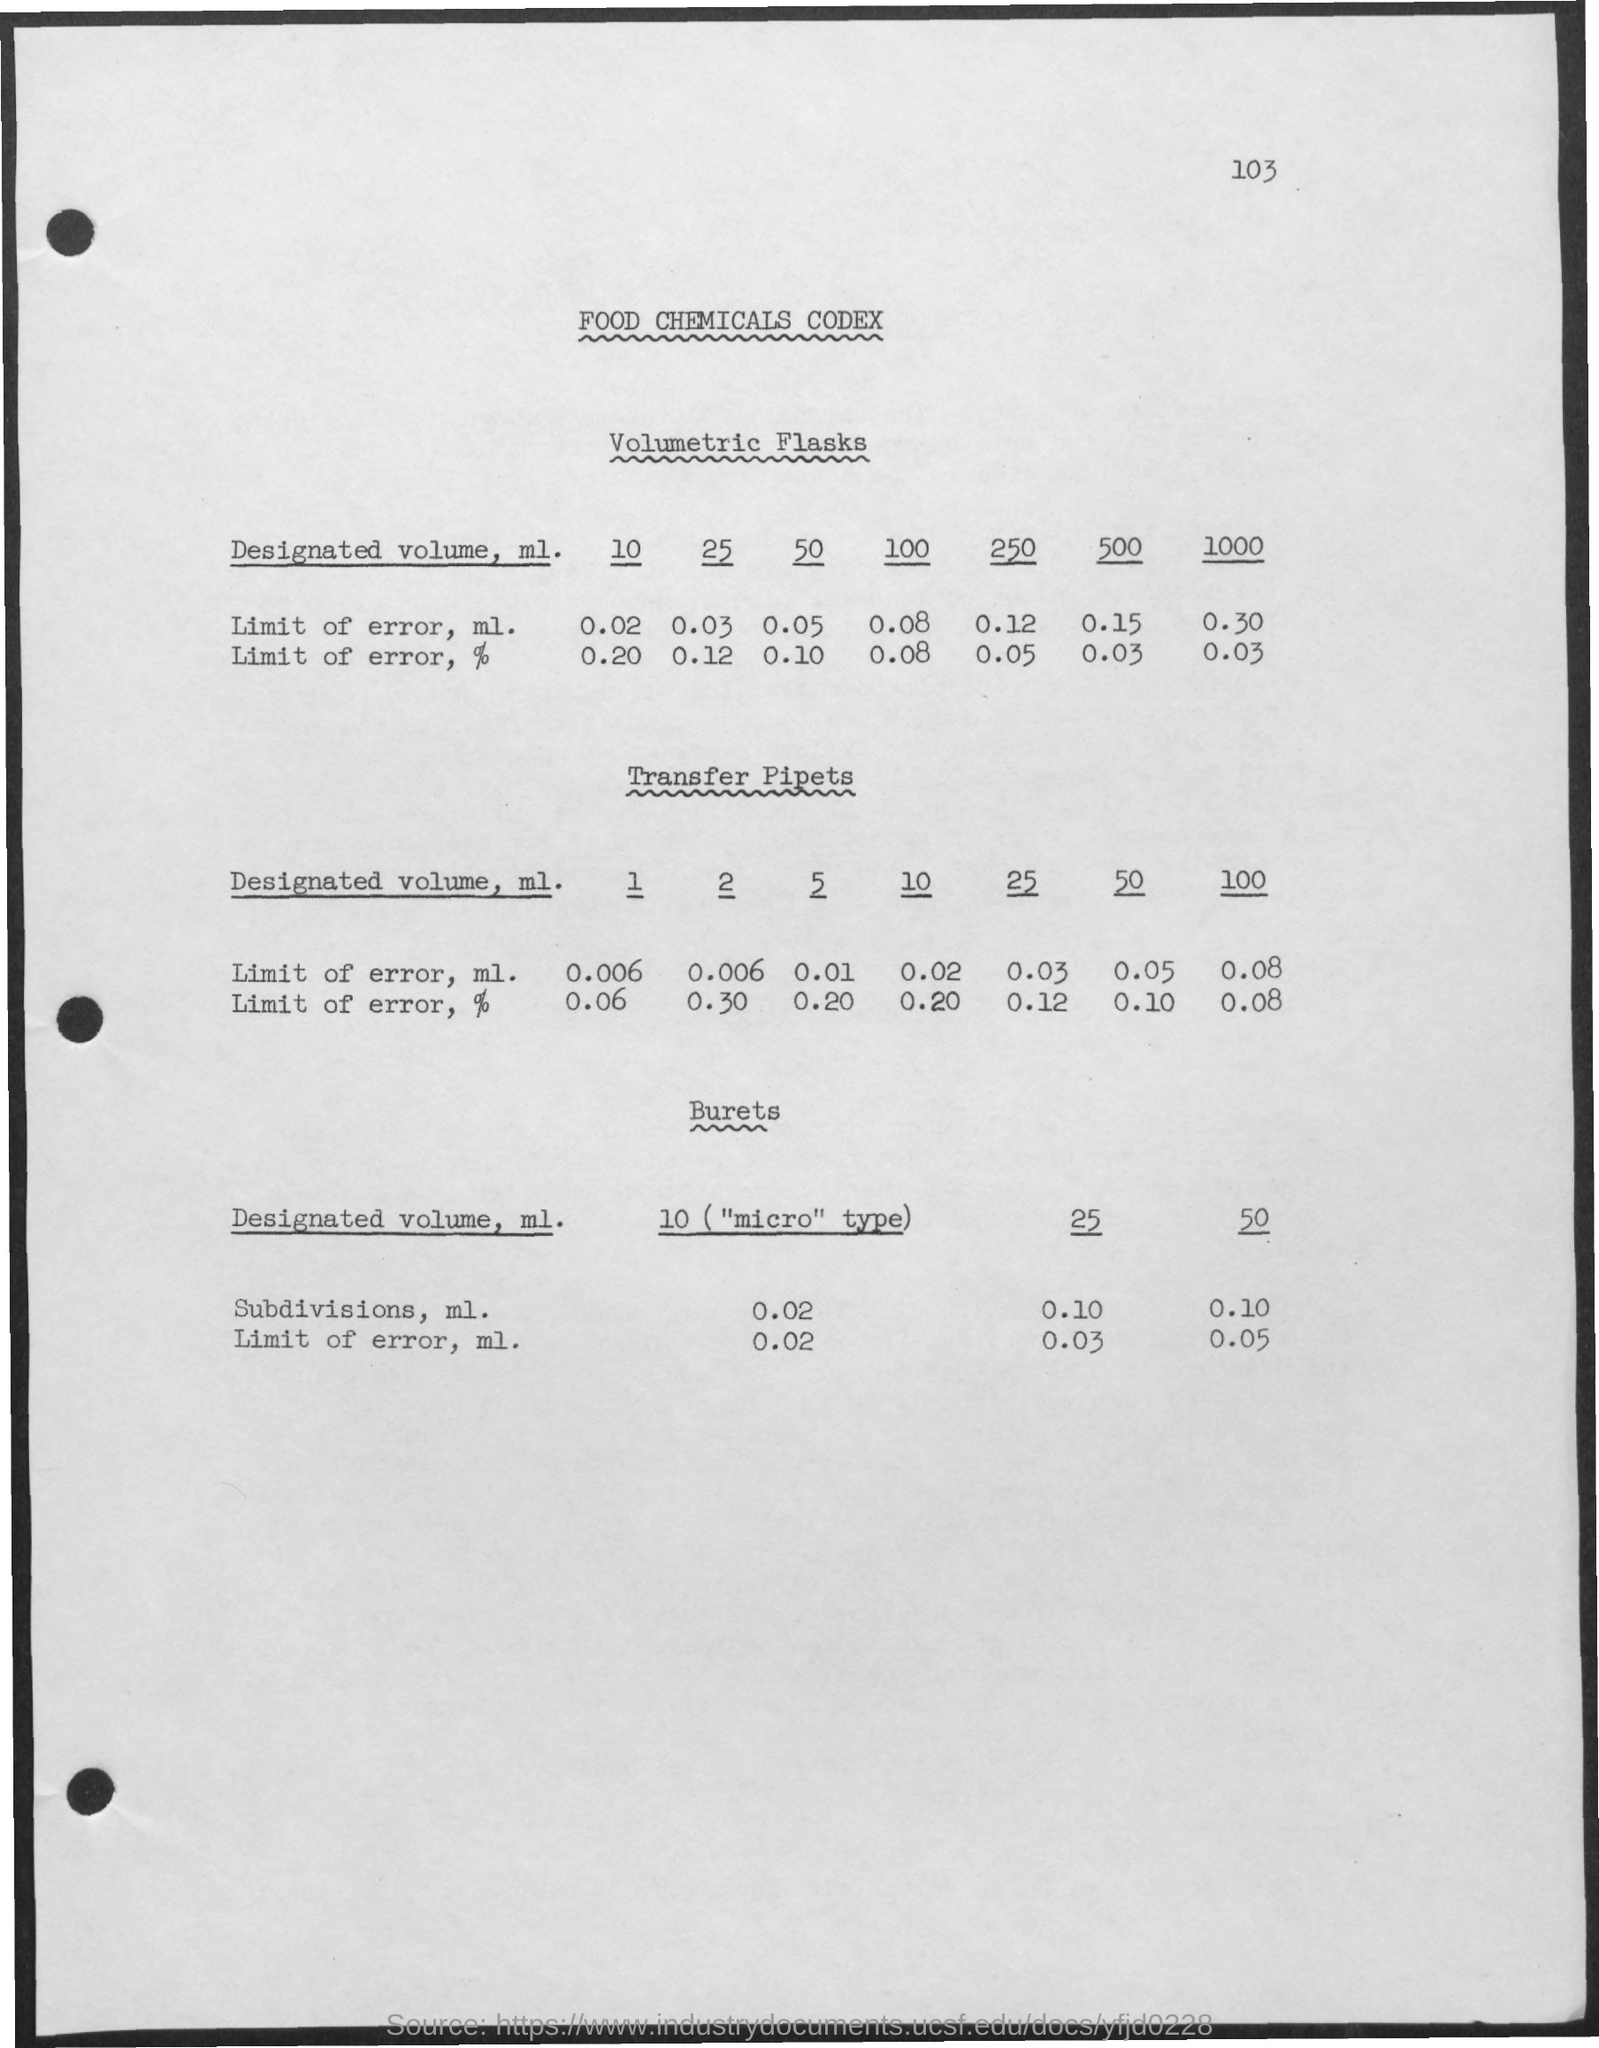What is the page number at top of the page?
Keep it short and to the point. 103. What is the heading of the document?
Give a very brief answer. Food Chemicals Codex. 